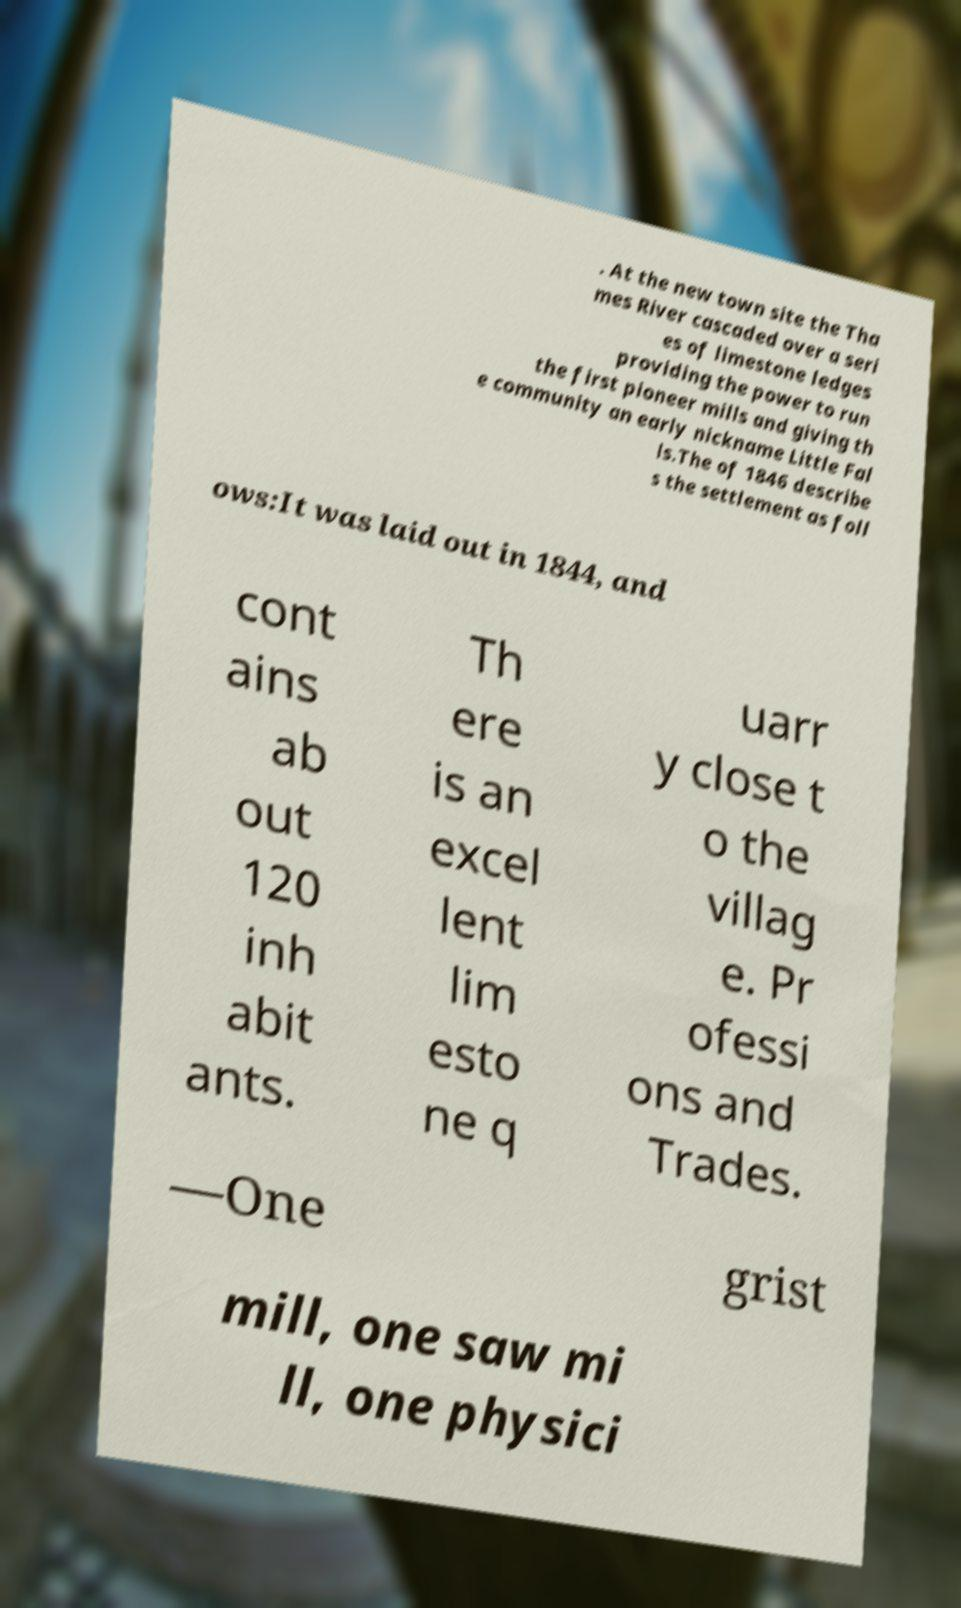Could you extract and type out the text from this image? . At the new town site the Tha mes River cascaded over a seri es of limestone ledges providing the power to run the first pioneer mills and giving th e community an early nickname Little Fal ls.The of 1846 describe s the settlement as foll ows:It was laid out in 1844, and cont ains ab out 120 inh abit ants. Th ere is an excel lent lim esto ne q uarr y close t o the villag e. Pr ofessi ons and Trades. —One grist mill, one saw mi ll, one physici 